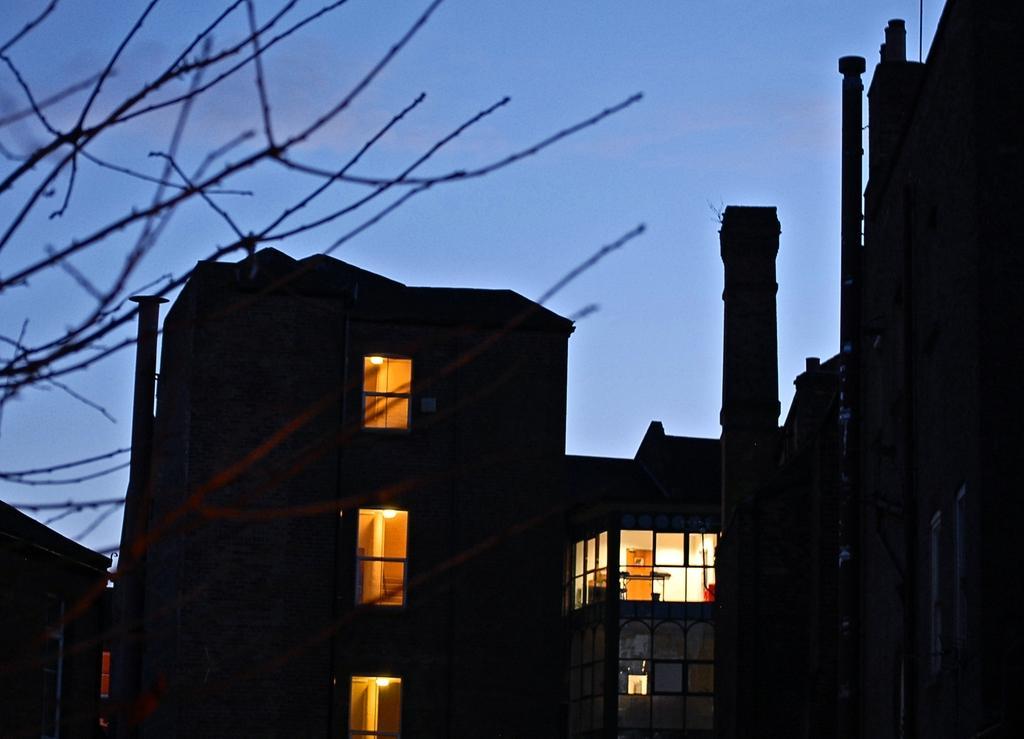How would you summarize this image in a sentence or two? In this picture we can see buildings, stairs and window. At the bottom we can see glasses, through that we can see the door, tablecloths, lights and television. On the left there is a tree. At the top there is a sky. 